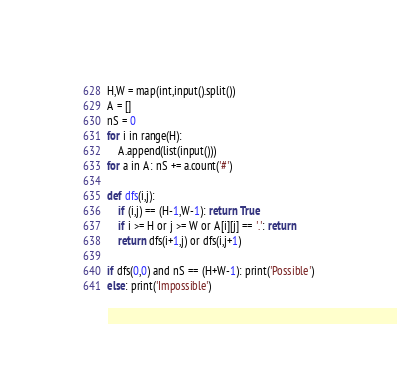<code> <loc_0><loc_0><loc_500><loc_500><_Python_>H,W = map(int,input().split())
A = []
nS = 0
for i in range(H):
    A.append(list(input()))
for a in A: nS += a.count('#')

def dfs(i,j):
    if (i,j) == (H-1,W-1): return True
    if i >= H or j >= W or A[i][j] == '.': return
    return dfs(i+1,j) or dfs(i,j+1)

if dfs(0,0) and nS == (H+W-1): print('Possible')
else: print('Impossible')</code> 